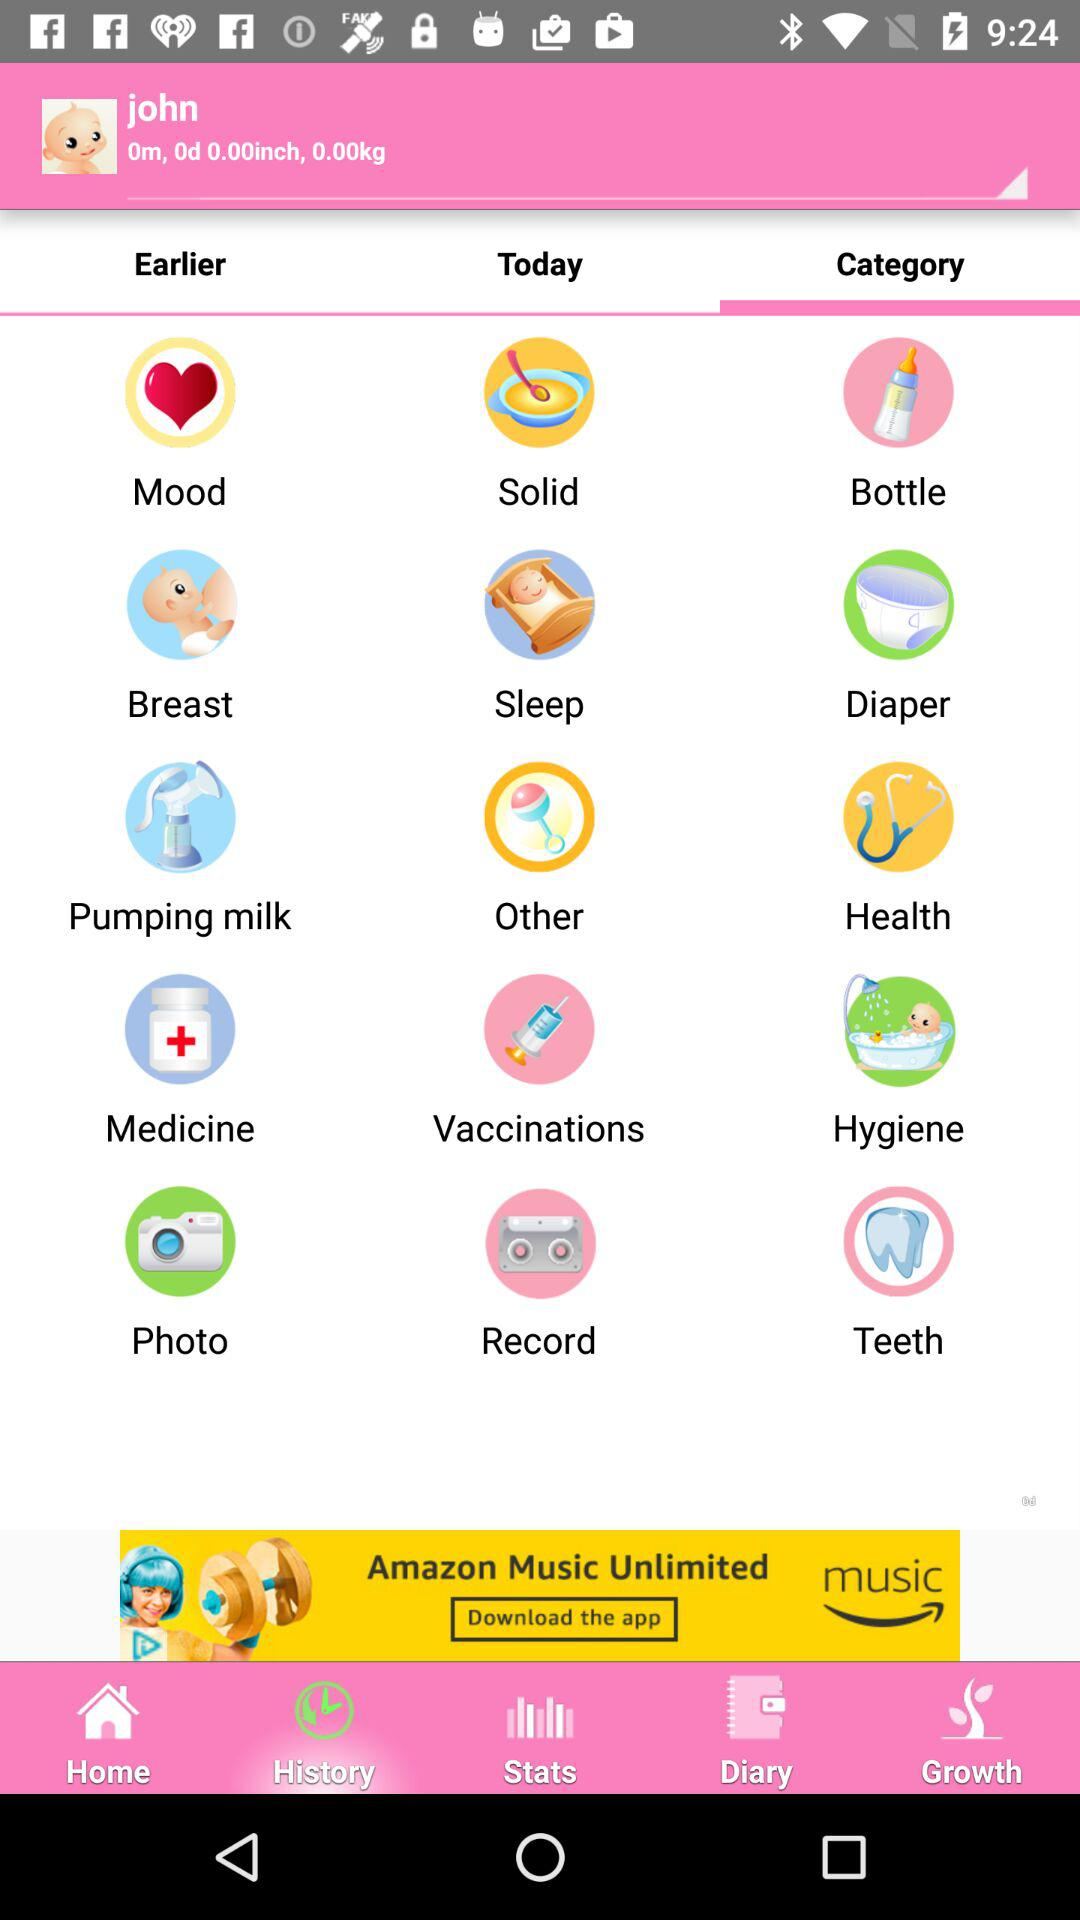What is the weight of the baby? The weight of the baby is 0 kg. 